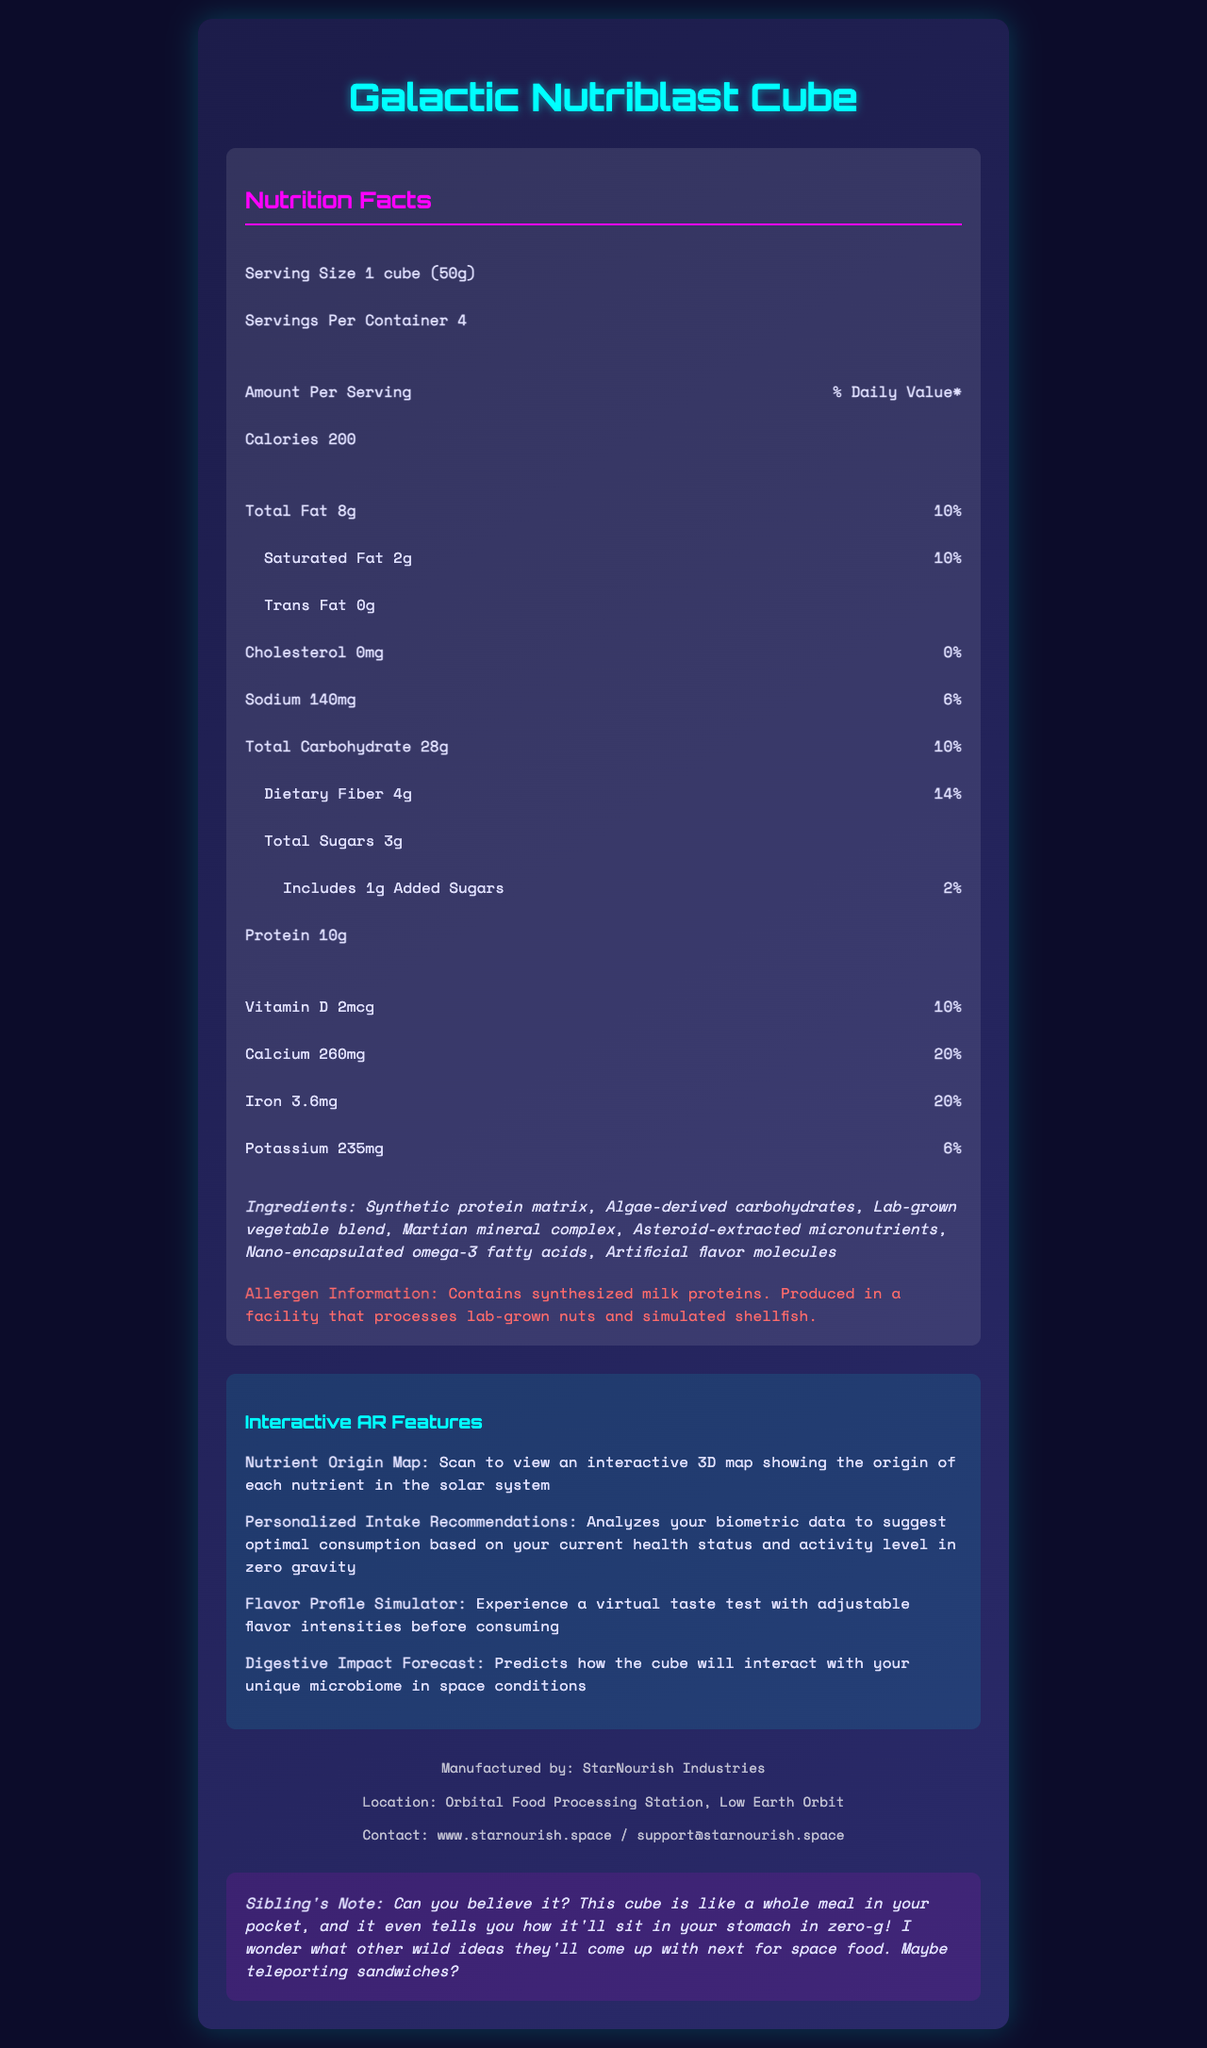what is the product name? The product name is displayed prominently at the top of the document.
Answer: Galactic Nutriblast Cube what is the serving size for the Galactic Nutriblast Cube? The serving size is listed as "1 cube (50g)" in the nutrition facts section.
Answer: 1 cube (50g) how many calories are there per serving? The calories per serving are listed as 200 in the nutrition facts section under "Calories".
Answer: 200 how much protein does each serving contain? The protein content per serving is listed as 10g in the nutrition facts section.
Answer: 10g what is the daily value percentage for Calcium? Calcium has a daily value percentage of 20% shown in the vitamins and minerals section.
Answer: 20% how many servings are there per container? The servings per container are listed as 4 in the nutrition facts section.
Answer: 4 what interactive feature helps you view nutrient sources? The Nutrient Origin Map is one of the interactive features listed, and it allows you to view the origin of each nutrient.
Answer: Nutrient Origin Map which of the following is an ingredient in the Galactic Nutriblast Cube? A. Synthetic protein matrix B. Real fruit extract C. Vegan cheese The ingredient "Synthetic protein matrix" is listed in the ingredients section, while "Real fruit extract" and "Vegan cheese" are not.
Answer: A. Synthetic protein matrix what is the percentage of daily value for dietary fiber per serving? A. 6% B. 10% C. 14% D. 20% The daily value percentage for dietary fiber per serving is listed as 14% in the nutrition facts section.
Answer: C. 14% does this product contain any trans fats? The trans fat content listed in the nutrition facts section is 0g, indicating no trans fats.
Answer: No please summarize the main features and information in the document. The summary includes the main features such as nutritional content, interactive tools, and manufacturer's information provided in the document.
Answer: The document provides a detailed overview of the Galactic Nutriblast Cube, including its nutrition facts, ingredients, allergen information, interactive AR features, and manufacturer details. Each serving of the cube is 50g, with 200 calories, 10g of protein, and various vitamins and minerals. The product is manufactured by StarNourish Industries and contains innovative interactive features such as a Nutrient Origin Map and a Flavor Profile Simulator. where is StarNourish Industries located? The manufacturer's location is provided in the manufacturer information section.
Answer: Orbital Food Processing Station, Low Earth Orbit what does the Digestive Impact Forecast feature do? The Digestive Impact Forecast's functionality is explained as predicting how the cube will interact with your microbiome in space conditions, listed in the interactive features section.
Answer: Predicts how the cube will interact with your unique microbiome in space conditions how many interactive AR features does the Galactic Nutriblast Cube have? The document lists four interactive AR features in the interactive features section.
Answer: Four are there any added sugars in each serving? It is mentioned in the nutrition facts section that there are includes 1g of added sugars.
Answer: Yes what is the contact information for StarNourish Industries? The document provides the website and the support email as the contact information for StarNourish Industries.
Answer: www.starnourish.space / support@starnourish.space what specific data do the Personalized Intake Recommendations analyze to provide suggestions? The document mentions that the Personalized Intake Recommendations analyze biometric data but does not specify which biometric data is analyzed.
Answer: Cannot be determined can you identify which nutrient has the highest daily value percentage? Both Calcium and Iron have the highest daily value percentage at 20%, as noted in the vitamins and minerals section.
Answer: Calcium and Iron (tie) 